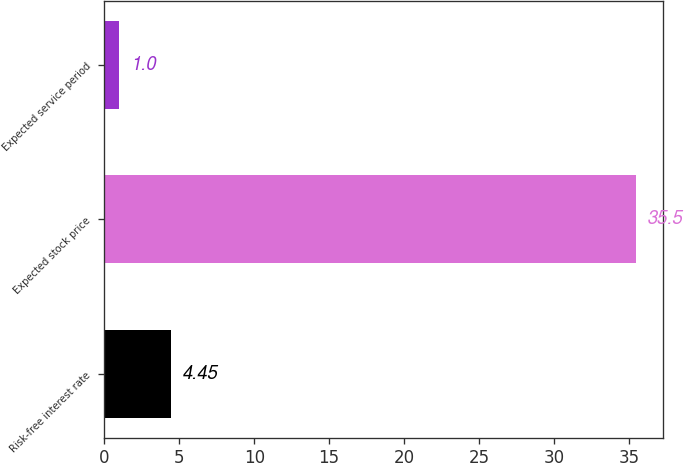Convert chart to OTSL. <chart><loc_0><loc_0><loc_500><loc_500><bar_chart><fcel>Risk-free interest rate<fcel>Expected stock price<fcel>Expected service period<nl><fcel>4.45<fcel>35.5<fcel>1<nl></chart> 